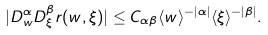Convert formula to latex. <formula><loc_0><loc_0><loc_500><loc_500>| D _ { w } ^ { \alpha } D _ { \xi } ^ { \beta } r ( w , \xi ) | \leq C _ { \alpha \beta } \langle w \rangle ^ { - | \alpha | } \langle \xi \rangle ^ { - | \beta | } .</formula> 